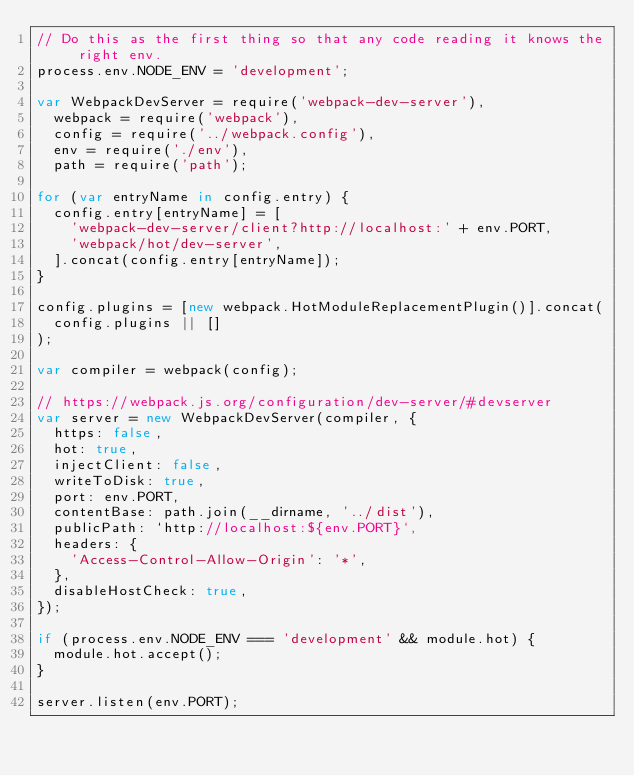Convert code to text. <code><loc_0><loc_0><loc_500><loc_500><_JavaScript_>// Do this as the first thing so that any code reading it knows the right env.
process.env.NODE_ENV = 'development';

var WebpackDevServer = require('webpack-dev-server'),
  webpack = require('webpack'),
  config = require('../webpack.config'),
  env = require('./env'),
  path = require('path');

for (var entryName in config.entry) {
  config.entry[entryName] = [
    'webpack-dev-server/client?http://localhost:' + env.PORT,
    'webpack/hot/dev-server',
  ].concat(config.entry[entryName]);
}

config.plugins = [new webpack.HotModuleReplacementPlugin()].concat(
  config.plugins || []
);

var compiler = webpack(config);

// https://webpack.js.org/configuration/dev-server/#devserver
var server = new WebpackDevServer(compiler, {
  https: false,
  hot: true,
  injectClient: false,
  writeToDisk: true,
  port: env.PORT,
  contentBase: path.join(__dirname, '../dist'),
  publicPath: `http://localhost:${env.PORT}`,
  headers: {
    'Access-Control-Allow-Origin': '*',
  },
  disableHostCheck: true,
});

if (process.env.NODE_ENV === 'development' && module.hot) {
  module.hot.accept();
}

server.listen(env.PORT);
</code> 